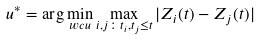Convert formula to latex. <formula><loc_0><loc_0><loc_500><loc_500>u ^ { * } = \arg \min _ { w c u } \max _ { i , j \colon t _ { i } , t _ { j } \leq t } | Z _ { i } ( t ) - Z _ { j } ( t ) |</formula> 